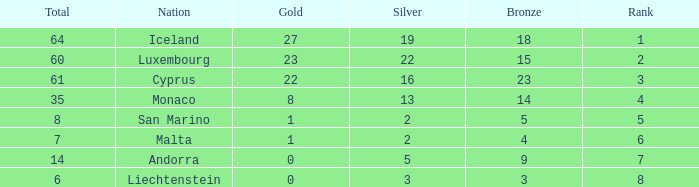How many bronzes for nations with over 22 golds and ranked under 2? 18.0. 